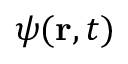Convert formula to latex. <formula><loc_0><loc_0><loc_500><loc_500>\psi ( { r } , t )</formula> 